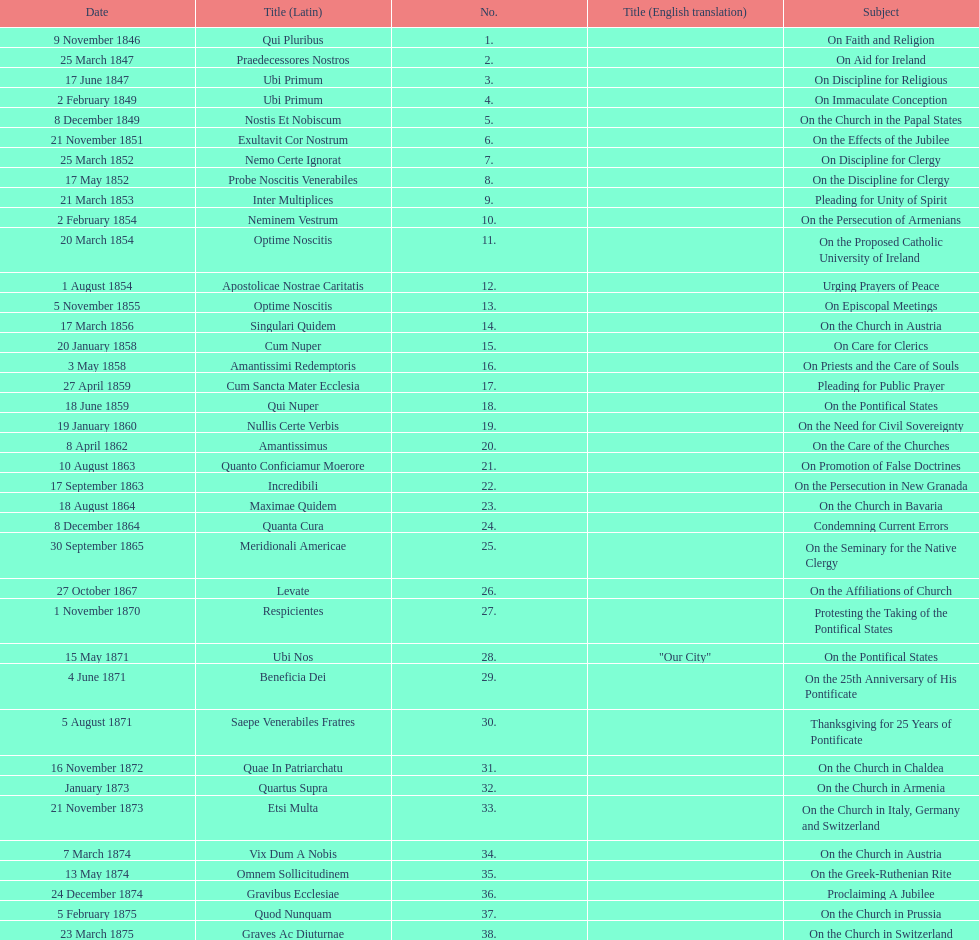What is the last title? Graves Ac Diuturnae. 